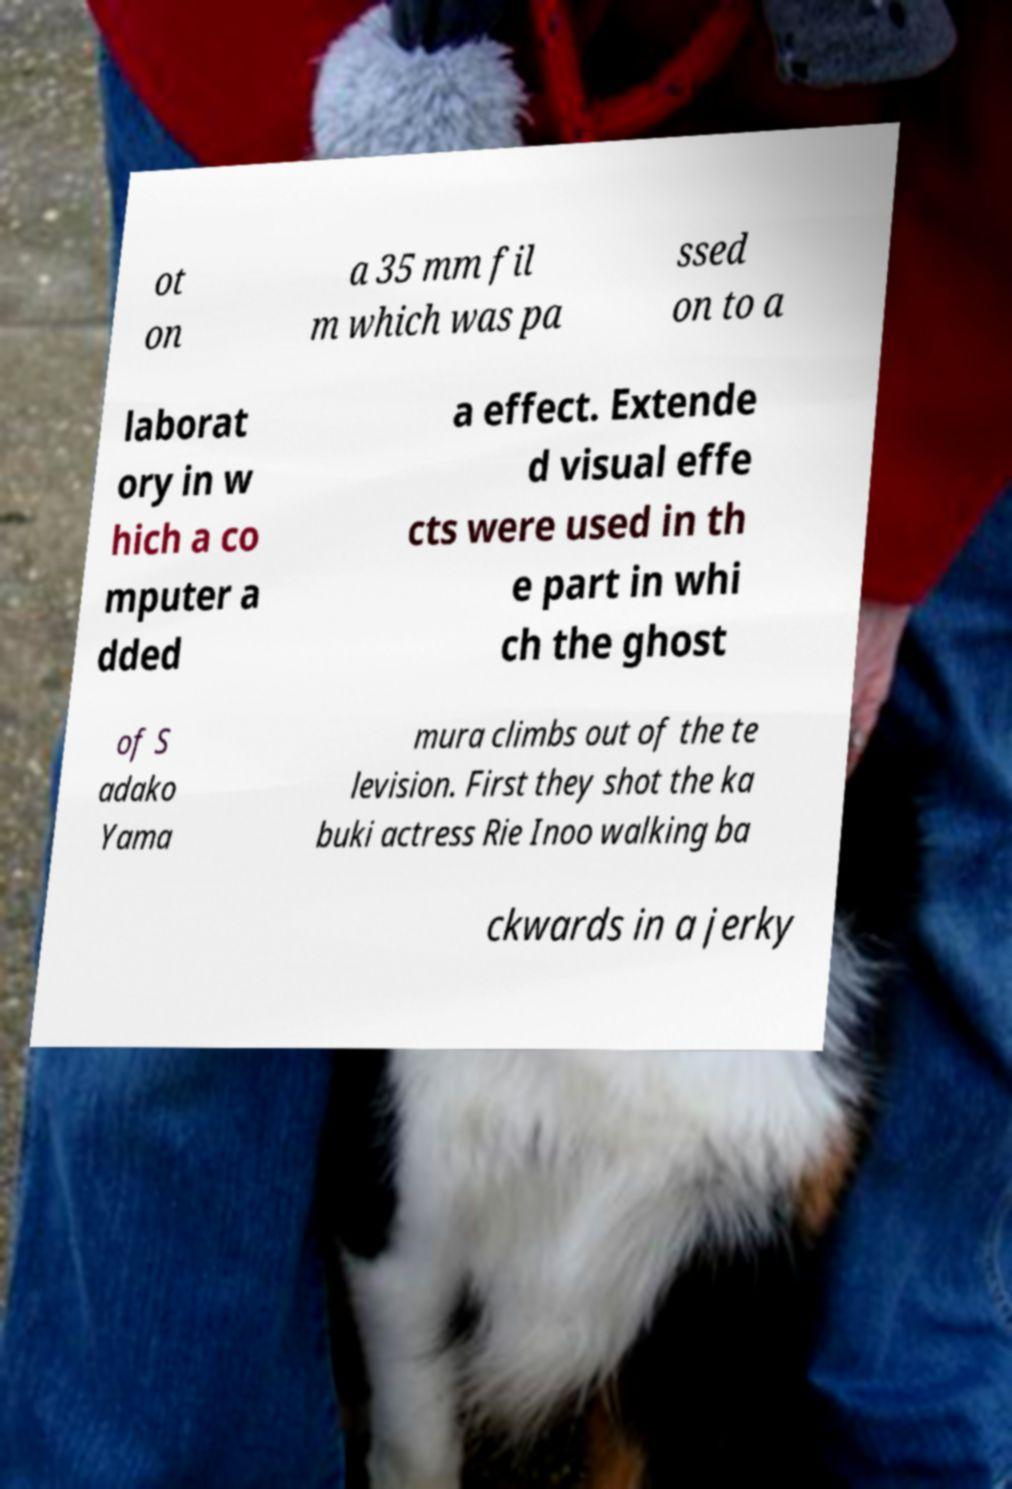There's text embedded in this image that I need extracted. Can you transcribe it verbatim? ot on a 35 mm fil m which was pa ssed on to a laborat ory in w hich a co mputer a dded a effect. Extende d visual effe cts were used in th e part in whi ch the ghost of S adako Yama mura climbs out of the te levision. First they shot the ka buki actress Rie Inoo walking ba ckwards in a jerky 